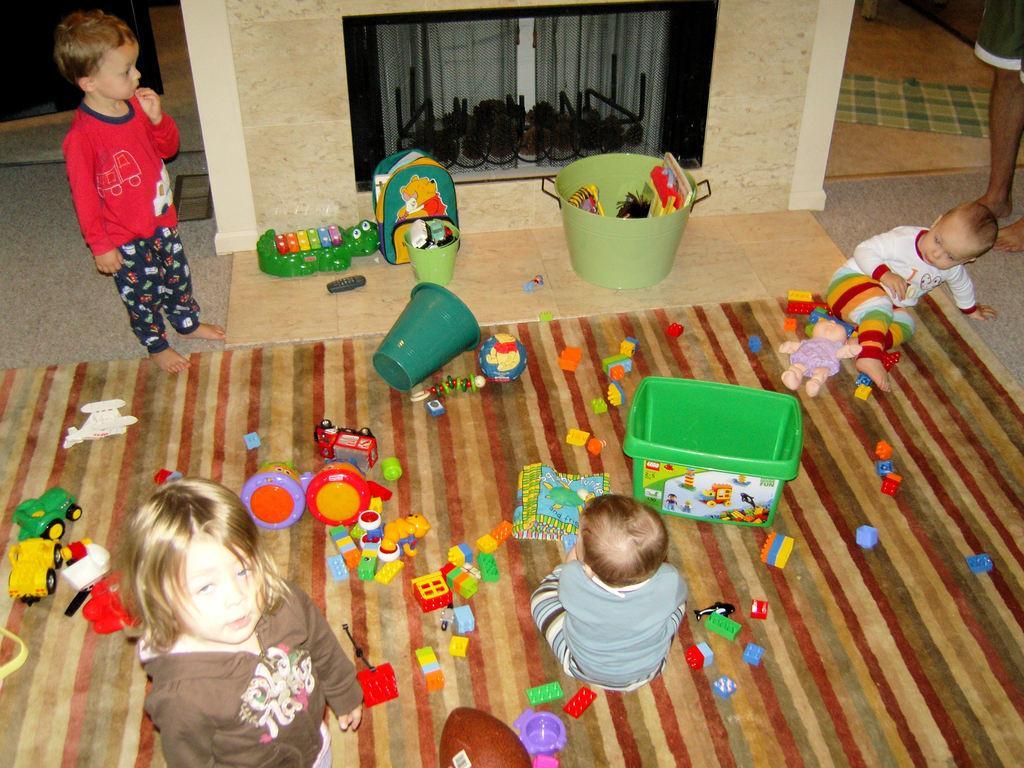Could you give a brief overview of what you see in this image? In this image there are kids standing and sitting. On the right side there is a person standing and on the ground there are toys, there are buckets and there is an object which is black in colour on the wall and on the ground there is a mat at the top right of the image. 